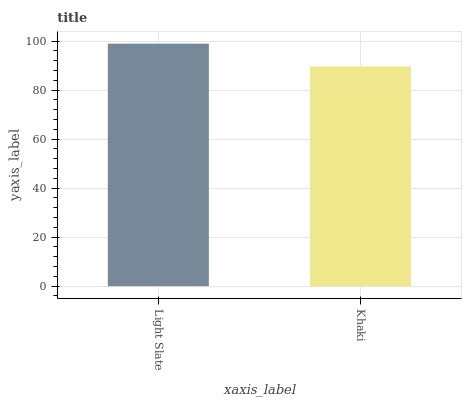Is Khaki the maximum?
Answer yes or no. No. Is Light Slate greater than Khaki?
Answer yes or no. Yes. Is Khaki less than Light Slate?
Answer yes or no. Yes. Is Khaki greater than Light Slate?
Answer yes or no. No. Is Light Slate less than Khaki?
Answer yes or no. No. Is Light Slate the high median?
Answer yes or no. Yes. Is Khaki the low median?
Answer yes or no. Yes. Is Khaki the high median?
Answer yes or no. No. Is Light Slate the low median?
Answer yes or no. No. 